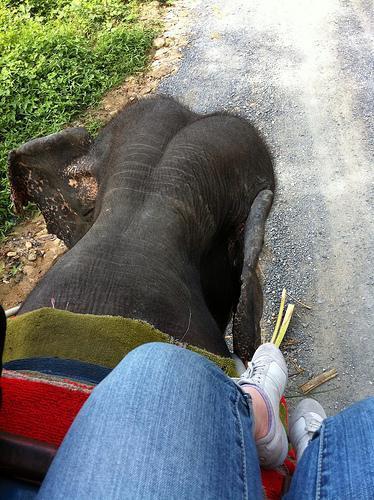How many human feet can we see?
Give a very brief answer. 2. How many people are under the elephant?
Give a very brief answer. 0. 